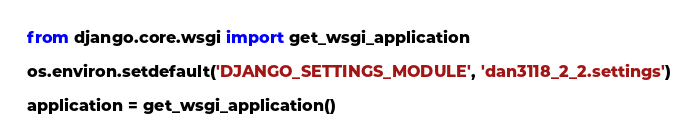Convert code to text. <code><loc_0><loc_0><loc_500><loc_500><_Python_>
from django.core.wsgi import get_wsgi_application

os.environ.setdefault('DJANGO_SETTINGS_MODULE', 'dan3118_2_2.settings')

application = get_wsgi_application()
</code> 